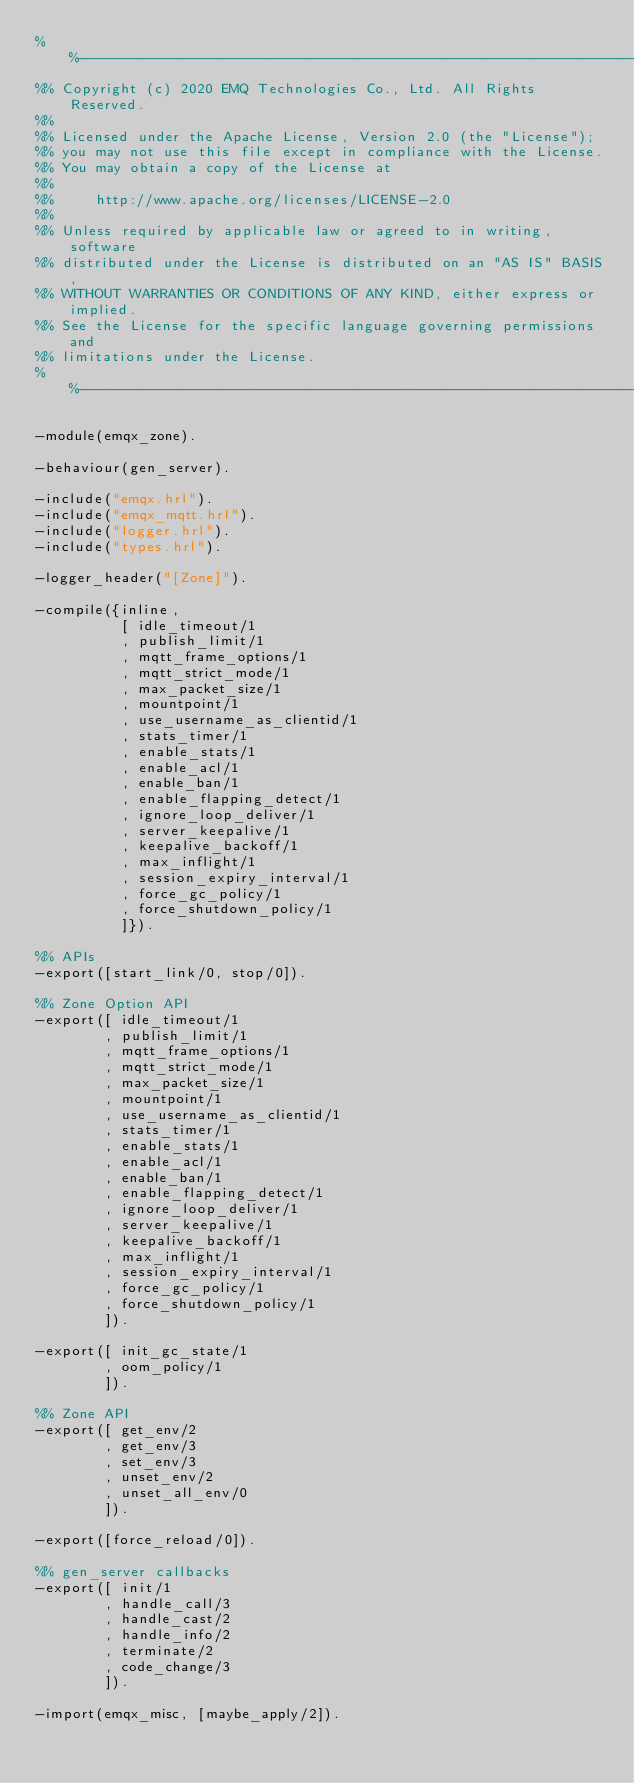Convert code to text. <code><loc_0><loc_0><loc_500><loc_500><_Erlang_>%%--------------------------------------------------------------------
%% Copyright (c) 2020 EMQ Technologies Co., Ltd. All Rights Reserved.
%%
%% Licensed under the Apache License, Version 2.0 (the "License");
%% you may not use this file except in compliance with the License.
%% You may obtain a copy of the License at
%%
%%     http://www.apache.org/licenses/LICENSE-2.0
%%
%% Unless required by applicable law or agreed to in writing, software
%% distributed under the License is distributed on an "AS IS" BASIS,
%% WITHOUT WARRANTIES OR CONDITIONS OF ANY KIND, either express or implied.
%% See the License for the specific language governing permissions and
%% limitations under the License.
%%--------------------------------------------------------------------

-module(emqx_zone).

-behaviour(gen_server).

-include("emqx.hrl").
-include("emqx_mqtt.hrl").
-include("logger.hrl").
-include("types.hrl").

-logger_header("[Zone]").

-compile({inline,
          [ idle_timeout/1
          , publish_limit/1
          , mqtt_frame_options/1
          , mqtt_strict_mode/1
          , max_packet_size/1
          , mountpoint/1
          , use_username_as_clientid/1
          , stats_timer/1
          , enable_stats/1
          , enable_acl/1
          , enable_ban/1
          , enable_flapping_detect/1
          , ignore_loop_deliver/1
          , server_keepalive/1
          , keepalive_backoff/1
          , max_inflight/1
          , session_expiry_interval/1
          , force_gc_policy/1
          , force_shutdown_policy/1
          ]}).

%% APIs
-export([start_link/0, stop/0]).

%% Zone Option API
-export([ idle_timeout/1
        , publish_limit/1
        , mqtt_frame_options/1
        , mqtt_strict_mode/1
        , max_packet_size/1
        , mountpoint/1
        , use_username_as_clientid/1
        , stats_timer/1
        , enable_stats/1
        , enable_acl/1
        , enable_ban/1
        , enable_flapping_detect/1
        , ignore_loop_deliver/1
        , server_keepalive/1
        , keepalive_backoff/1
        , max_inflight/1
        , session_expiry_interval/1
        , force_gc_policy/1
        , force_shutdown_policy/1
        ]).

-export([ init_gc_state/1
        , oom_policy/1
        ]).

%% Zone API
-export([ get_env/2
        , get_env/3
        , set_env/3
        , unset_env/2
        , unset_all_env/0
        ]).

-export([force_reload/0]).

%% gen_server callbacks
-export([ init/1
        , handle_call/3
        , handle_cast/2
        , handle_info/2
        , terminate/2
        , code_change/3
        ]).

-import(emqx_misc, [maybe_apply/2]).
</code> 